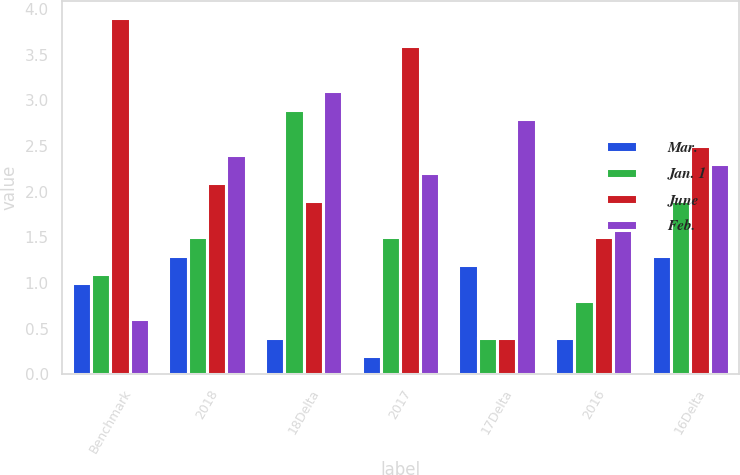Convert chart to OTSL. <chart><loc_0><loc_0><loc_500><loc_500><stacked_bar_chart><ecel><fcel>Benchmark<fcel>2018<fcel>18Delta<fcel>2017<fcel>17Delta<fcel>2016<fcel>16Delta<nl><fcel>Mar.<fcel>1<fcel>1.3<fcel>0.4<fcel>0.2<fcel>1.2<fcel>0.4<fcel>1.3<nl><fcel>Jan. 1<fcel>1.1<fcel>1.5<fcel>2.9<fcel>1.5<fcel>0.4<fcel>0.8<fcel>1.9<nl><fcel>June<fcel>3.9<fcel>2.1<fcel>1.9<fcel>3.6<fcel>0.4<fcel>1.5<fcel>2.5<nl><fcel>Feb.<fcel>0.6<fcel>2.4<fcel>3.1<fcel>2.2<fcel>2.8<fcel>1.7<fcel>2.3<nl></chart> 